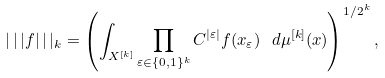Convert formula to latex. <formula><loc_0><loc_0><loc_500><loc_500>| \, | \, | f | \, | \, | _ { k } = \left ( \int _ { X ^ { [ k ] } } \prod _ { \varepsilon \in \{ 0 , 1 \} ^ { k } } C ^ { | \varepsilon | } f ( x _ { \varepsilon } ) \ d \mu ^ { [ k ] } ( x ) \right ) ^ { 1 / 2 ^ { k } } ,</formula> 